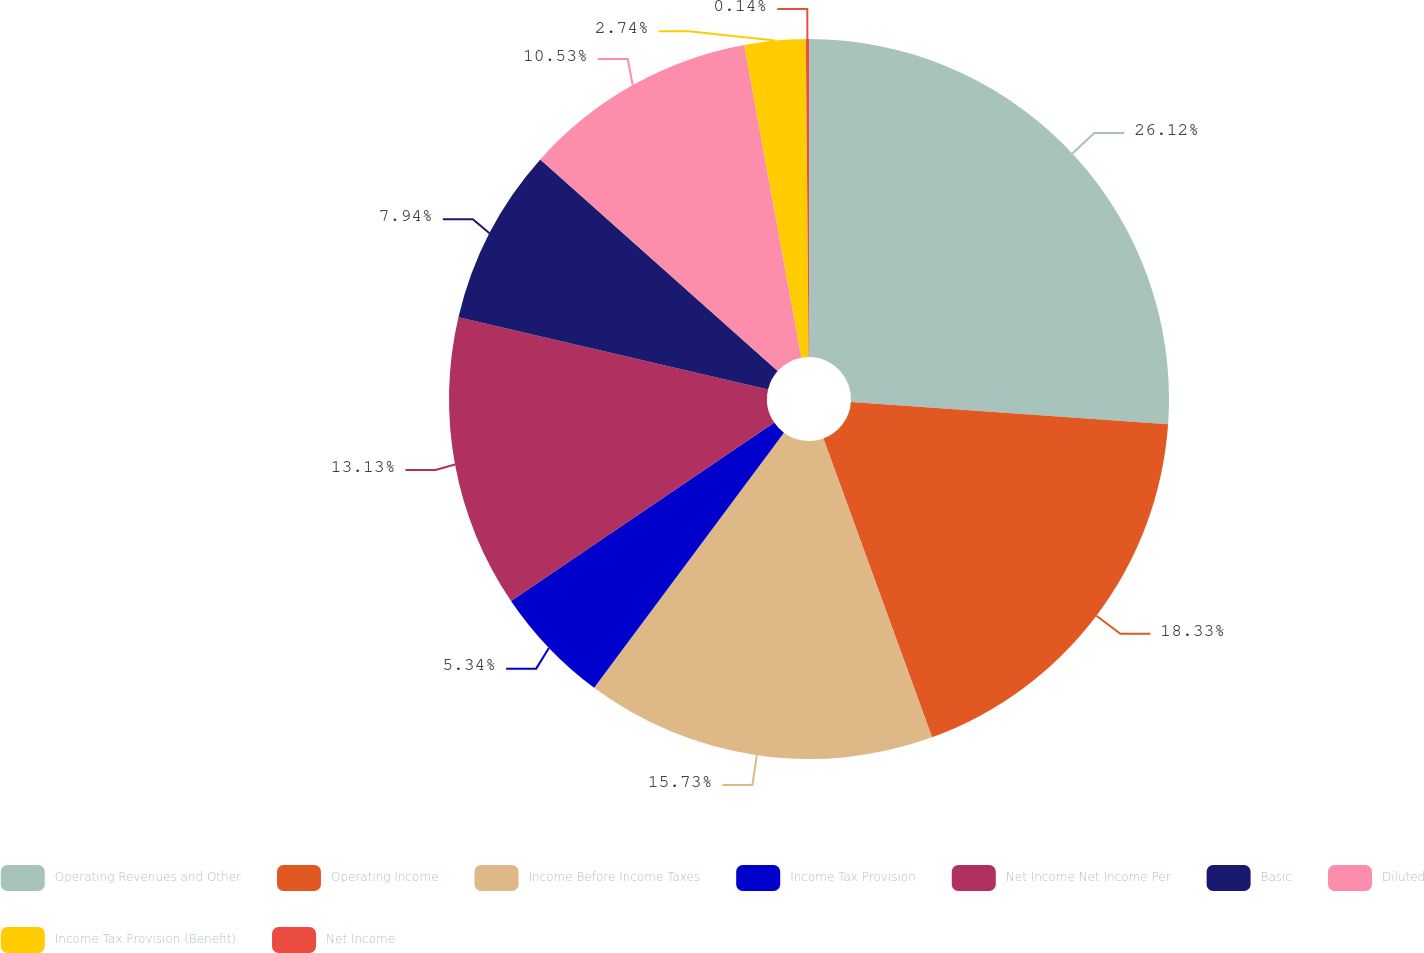Convert chart. <chart><loc_0><loc_0><loc_500><loc_500><pie_chart><fcel>Operating Revenues and Other<fcel>Operating Income<fcel>Income Before Income Taxes<fcel>Income Tax Provision<fcel>Net Income Net Income Per<fcel>Basic<fcel>Diluted<fcel>Income Tax Provision (Benefit)<fcel>Net Income<nl><fcel>26.12%<fcel>18.33%<fcel>15.73%<fcel>5.34%<fcel>13.13%<fcel>7.94%<fcel>10.53%<fcel>2.74%<fcel>0.14%<nl></chart> 